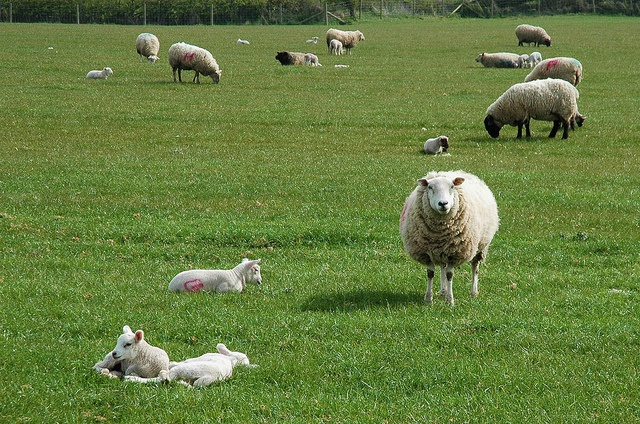Describe the objects in this image and their specific colors. I can see sheep in darkgreen, ivory, black, and gray tones, sheep in darkgreen, black, gray, and darkgray tones, sheep in darkgreen and olive tones, sheep in darkgreen, darkgray, gray, and lightgray tones, and sheep in darkgreen, darkgray, lightgray, and gray tones in this image. 